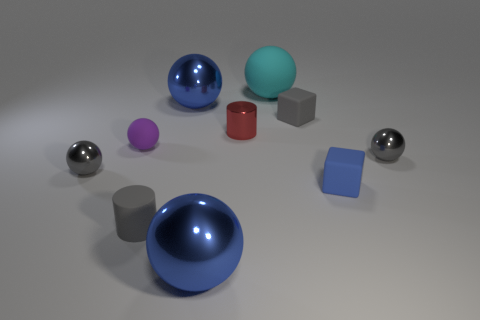Subtract all purple spheres. How many spheres are left? 5 Subtract all tiny gray balls. How many balls are left? 4 Subtract all brown spheres. Subtract all purple cylinders. How many spheres are left? 6 Subtract all spheres. How many objects are left? 4 Subtract all rubber objects. Subtract all small purple matte things. How many objects are left? 4 Add 1 gray rubber cylinders. How many gray rubber cylinders are left? 2 Add 4 gray rubber objects. How many gray rubber objects exist? 6 Subtract 1 gray cylinders. How many objects are left? 9 